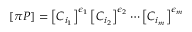<formula> <loc_0><loc_0><loc_500><loc_500>\left [ \pi P \right ] = \left [ C _ { i _ { 1 } } \right ] ^ { \epsilon _ { 1 } } \left [ C _ { i _ { 2 } } \right ] ^ { \epsilon _ { 2 } } \cdots \left [ C _ { i _ { m } } \right ] ^ { \epsilon _ { m } }</formula> 